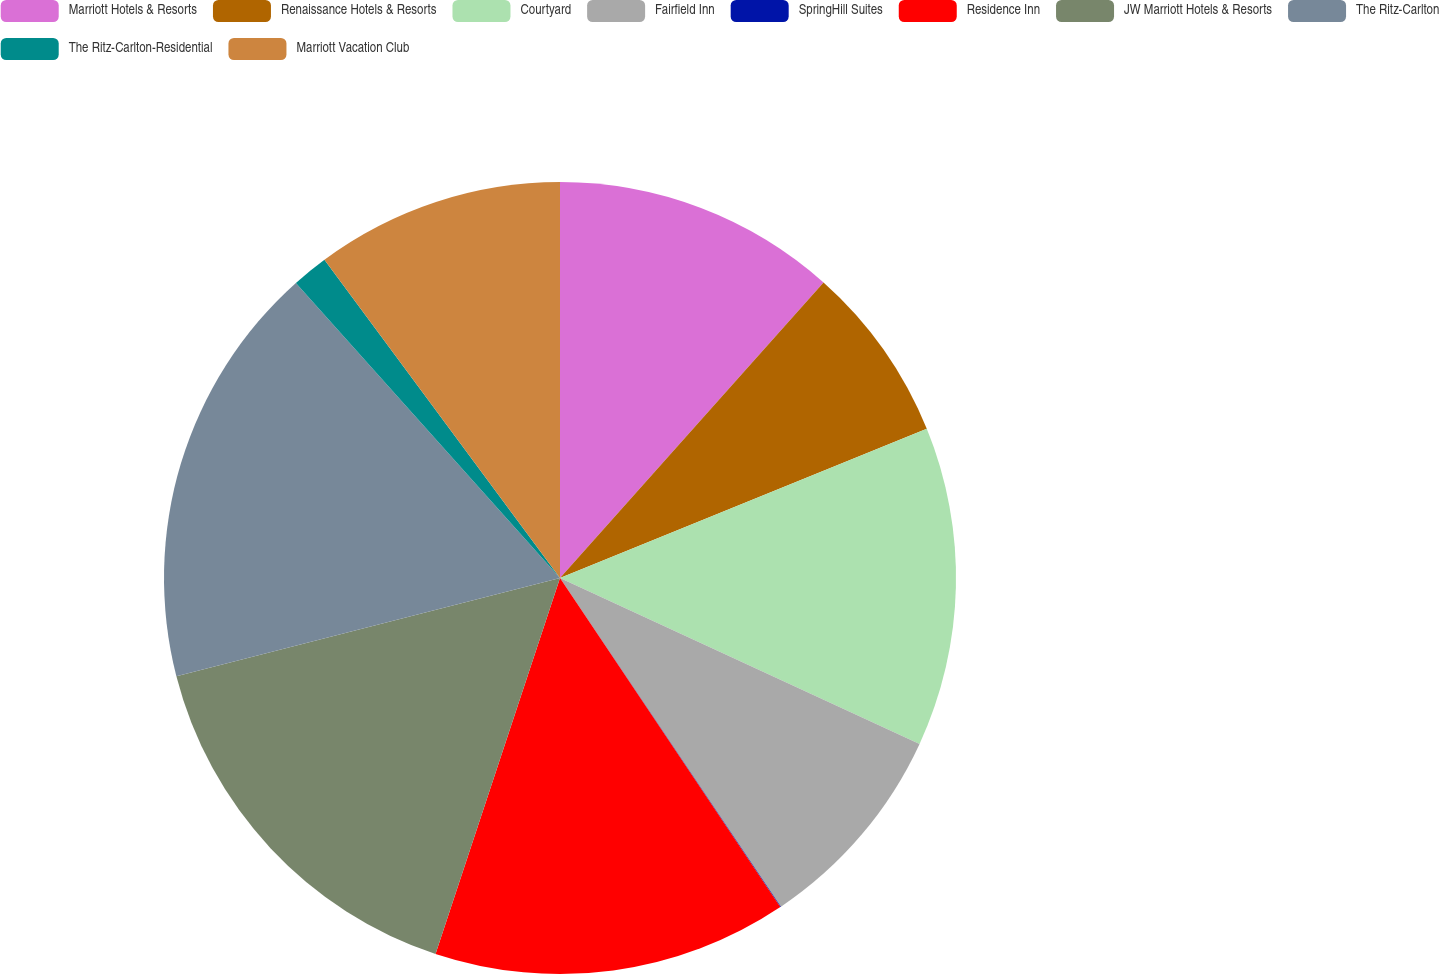<chart> <loc_0><loc_0><loc_500><loc_500><pie_chart><fcel>Marriott Hotels & Resorts<fcel>Renaissance Hotels & Resorts<fcel>Courtyard<fcel>Fairfield Inn<fcel>SpringHill Suites<fcel>Residence Inn<fcel>JW Marriott Hotels & Resorts<fcel>The Ritz-Carlton<fcel>The Ritz-Carlton-Residential<fcel>Marriott Vacation Club<nl><fcel>11.59%<fcel>7.26%<fcel>13.03%<fcel>8.7%<fcel>0.03%<fcel>14.48%<fcel>15.92%<fcel>17.37%<fcel>1.48%<fcel>10.14%<nl></chart> 